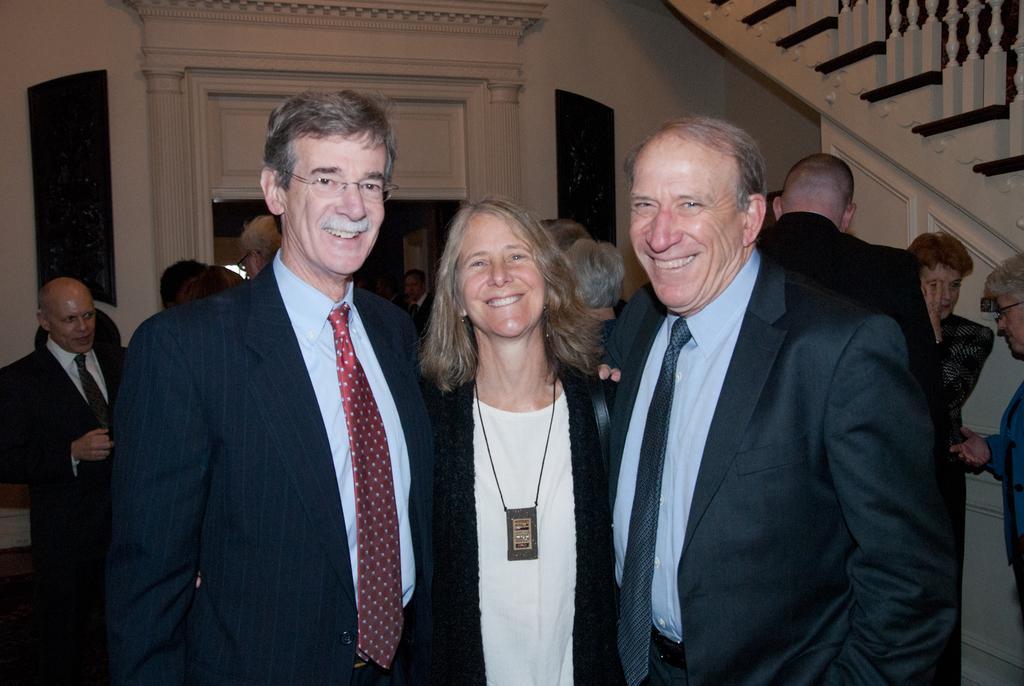Describe this image in one or two sentences. In this picture there people, among them there are three people standing and smiling. In the background of the image we can see wall, railing and frames. 